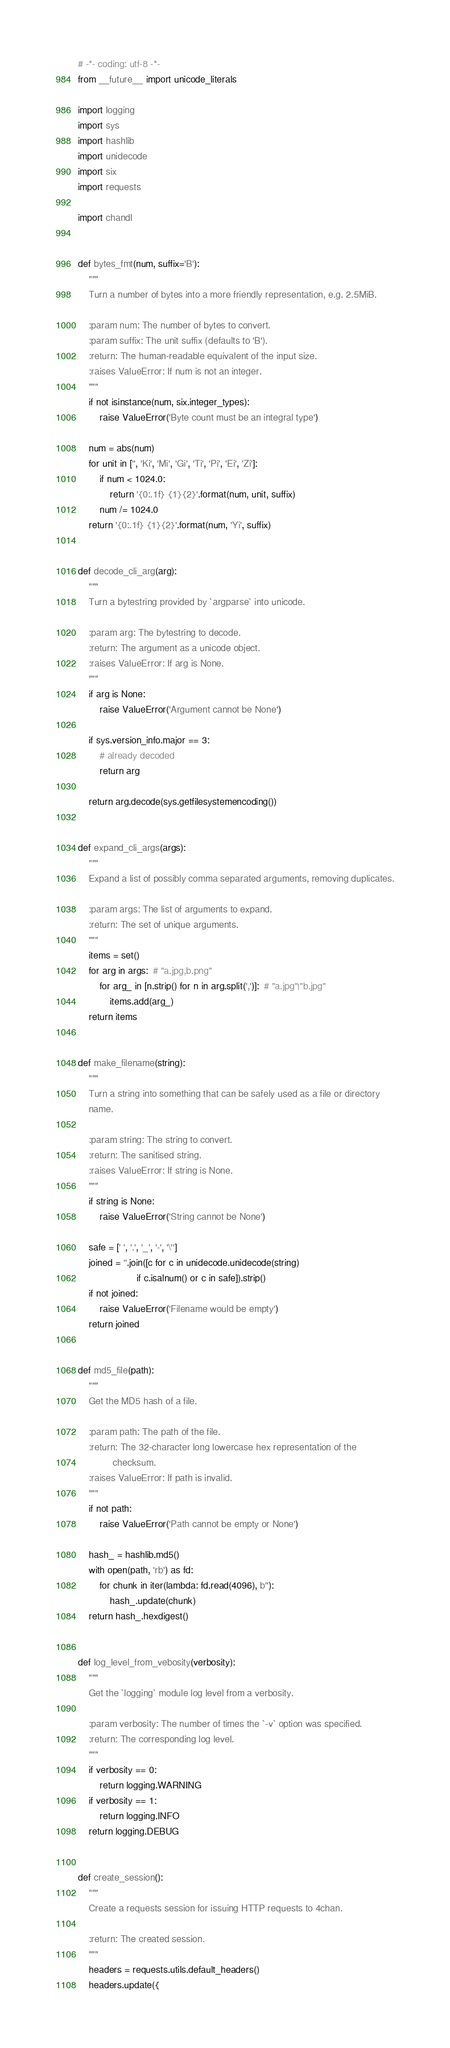Convert code to text. <code><loc_0><loc_0><loc_500><loc_500><_Python_># -*- coding: utf-8 -*-
from __future__ import unicode_literals

import logging
import sys
import hashlib
import unidecode
import six
import requests

import chandl


def bytes_fmt(num, suffix='B'):
    """
    Turn a number of bytes into a more friendly representation, e.g. 2.5MiB.

    :param num: The number of bytes to convert.
    :param suffix: The unit suffix (defaults to 'B').
    :return: The human-readable equivalent of the input size.
    :raises ValueError: If num is not an integer.
    """
    if not isinstance(num, six.integer_types):
        raise ValueError('Byte count must be an integral type')

    num = abs(num)
    for unit in ['', 'Ki', 'Mi', 'Gi', 'Ti', 'Pi', 'Ei', 'Zi']:
        if num < 1024.0:
            return '{0:.1f} {1}{2}'.format(num, unit, suffix)
        num /= 1024.0
    return '{0:.1f} {1}{2}'.format(num, 'Yi', suffix)


def decode_cli_arg(arg):
    """
    Turn a bytestring provided by `argparse` into unicode.

    :param arg: The bytestring to decode.
    :return: The argument as a unicode object.
    :raises ValueError: If arg is None.
    """
    if arg is None:
        raise ValueError('Argument cannot be None')

    if sys.version_info.major == 3:
        # already decoded
        return arg

    return arg.decode(sys.getfilesystemencoding())


def expand_cli_args(args):
    """
    Expand a list of possibly comma separated arguments, removing duplicates.

    :param args: The list of arguments to expand.
    :return: The set of unique arguments.
    """
    items = set()
    for arg in args:  # "a.jpg,b.png"
        for arg_ in [n.strip() for n in arg.split(',')]:  # "a.jpg"|"b.jpg"
            items.add(arg_)
    return items


def make_filename(string):
    """
    Turn a string into something that can be safely used as a file or directory
    name.

    :param string: The string to convert.
    :return: The sanitised string.
    :raises ValueError: If string is None.
    """
    if string is None:
        raise ValueError('String cannot be None')

    safe = [' ', '.', '_', '-', '\'']
    joined = ''.join([c for c in unidecode.unidecode(string)
                      if c.isalnum() or c in safe]).strip()
    if not joined:
        raise ValueError('Filename would be empty')
    return joined


def md5_file(path):
    """
    Get the MD5 hash of a file.

    :param path: The path of the file.
    :return: The 32-character long lowercase hex representation of the
             checksum.
    :raises ValueError: If path is invalid.
    """
    if not path:
        raise ValueError('Path cannot be empty or None')

    hash_ = hashlib.md5()
    with open(path, 'rb') as fd:
        for chunk in iter(lambda: fd.read(4096), b''):
            hash_.update(chunk)
    return hash_.hexdigest()


def log_level_from_vebosity(verbosity):
    """
    Get the `logging` module log level from a verbosity.

    :param verbosity: The number of times the `-v` option was specified.
    :return: The corresponding log level.
    """
    if verbosity == 0:
        return logging.WARNING
    if verbosity == 1:
        return logging.INFO
    return logging.DEBUG


def create_session():
    """
    Create a requests session for issuing HTTP requests to 4chan.

    :return: The created session.
    """
    headers = requests.utils.default_headers()
    headers.update({</code> 